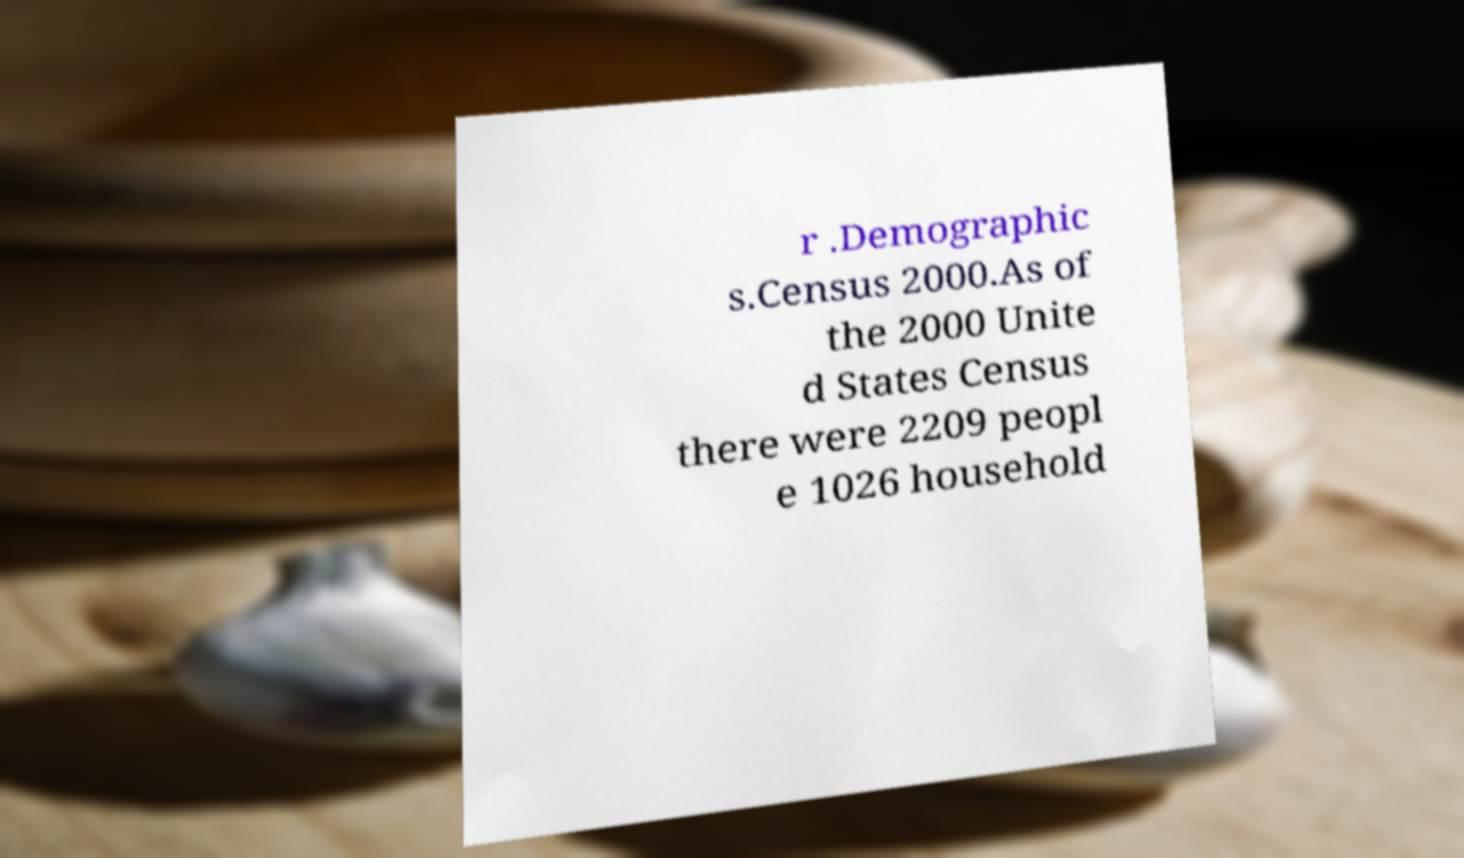There's text embedded in this image that I need extracted. Can you transcribe it verbatim? r .Demographic s.Census 2000.As of the 2000 Unite d States Census there were 2209 peopl e 1026 household 